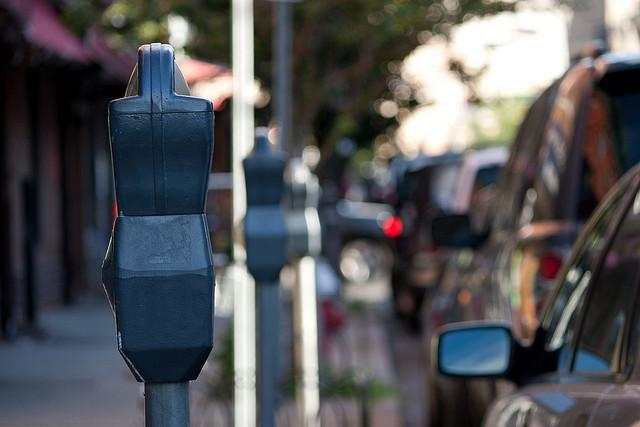What is to the left of the cars?

Choices:
A) dog
B) bicycles
C) parking meters
D) cats parking meters 